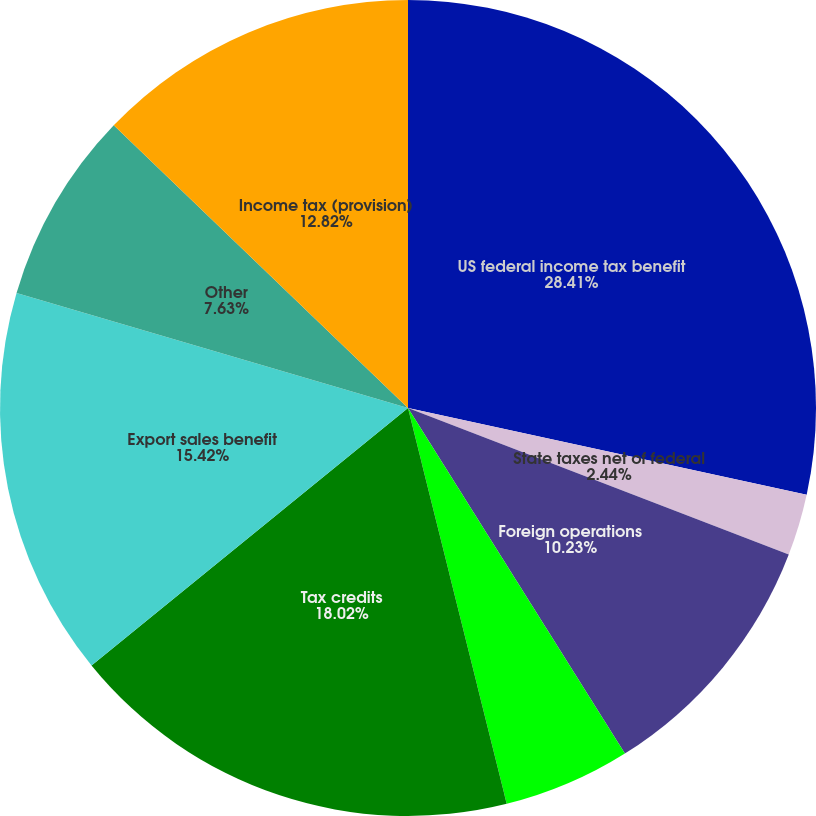Convert chart. <chart><loc_0><loc_0><loc_500><loc_500><pie_chart><fcel>US federal income tax benefit<fcel>State taxes net of federal<fcel>Foreign operations<fcel>Change in valuation allowance<fcel>Tax credits<fcel>Export sales benefit<fcel>Other<fcel>Income tax (provision)<nl><fcel>28.41%<fcel>2.44%<fcel>10.23%<fcel>5.03%<fcel>18.02%<fcel>15.42%<fcel>7.63%<fcel>12.82%<nl></chart> 